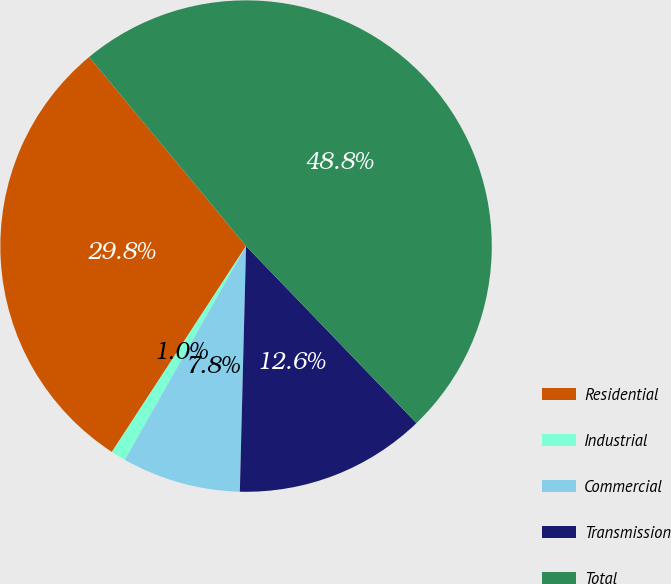Convert chart to OTSL. <chart><loc_0><loc_0><loc_500><loc_500><pie_chart><fcel>Residential<fcel>Industrial<fcel>Commercial<fcel>Transmission<fcel>Total<nl><fcel>29.79%<fcel>0.98%<fcel>7.81%<fcel>12.6%<fcel>48.83%<nl></chart> 